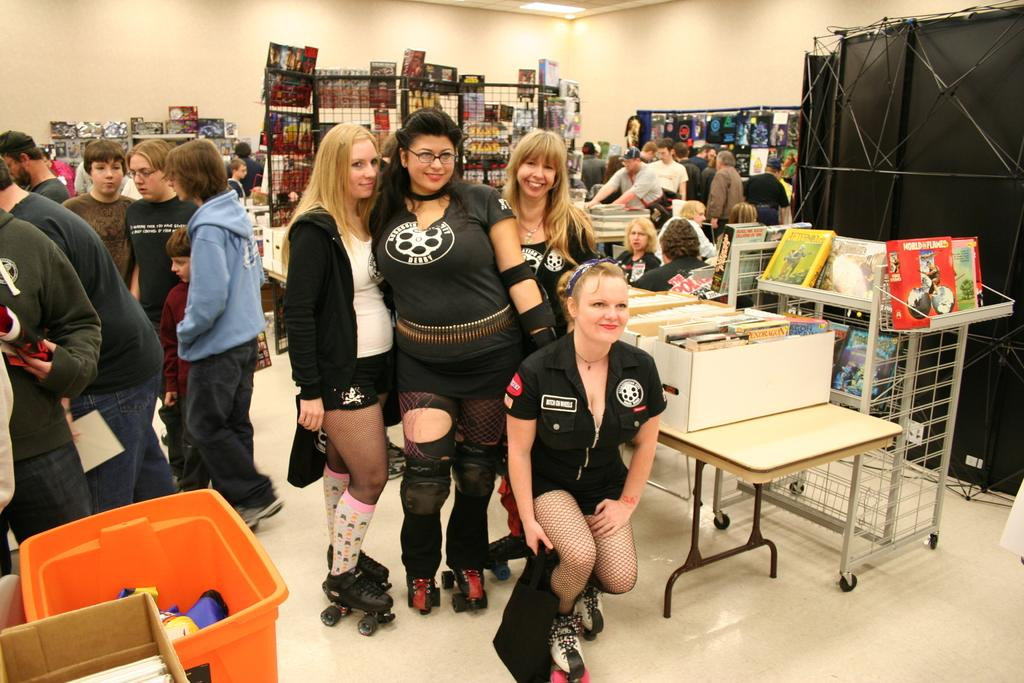What is the setting of the image? The people are standing in a store. What are the people in the image doing? There are people standing and seated in the image. What items can be seen on a table in the image? There are books on a table in the image. What can be seen in the background of the image? There is a rack visible in the background of the image. What type of reward is being given to the person with the longest toe in the image? There is no mention of toes or rewards in the image; it features a group of people in a store with books and a rack in the background. 